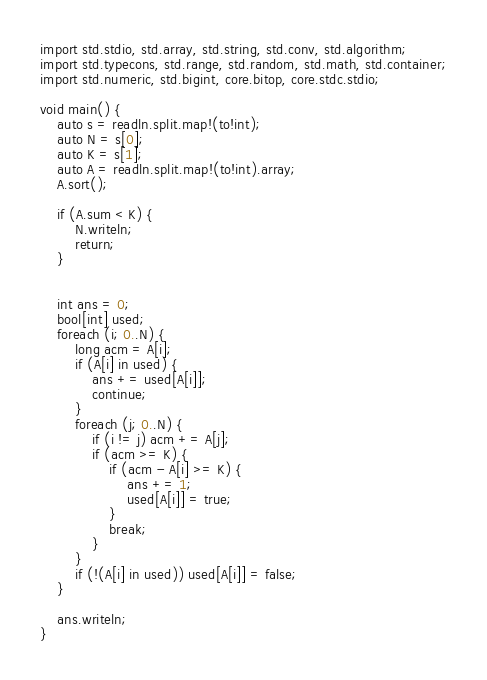<code> <loc_0><loc_0><loc_500><loc_500><_D_>import std.stdio, std.array, std.string, std.conv, std.algorithm;
import std.typecons, std.range, std.random, std.math, std.container;
import std.numeric, std.bigint, core.bitop, core.stdc.stdio;

void main() {
    auto s = readln.split.map!(to!int);
    auto N = s[0];
    auto K = s[1];
    auto A = readln.split.map!(to!int).array;
    A.sort();

    if (A.sum < K) {
        N.writeln;
        return;
    }


    int ans = 0;
    bool[int] used;
    foreach (i; 0..N) {
        long acm = A[i];
        if (A[i] in used) {
            ans += used[A[i]];
            continue;
        }
        foreach (j; 0..N) {
            if (i != j) acm += A[j];
            if (acm >= K) {
                if (acm - A[i] >= K) {
                    ans += 1;
                    used[A[i]] = true;
                }
                break;
            }
        }
        if (!(A[i] in used)) used[A[i]] = false;
    }

    ans.writeln;
}
</code> 